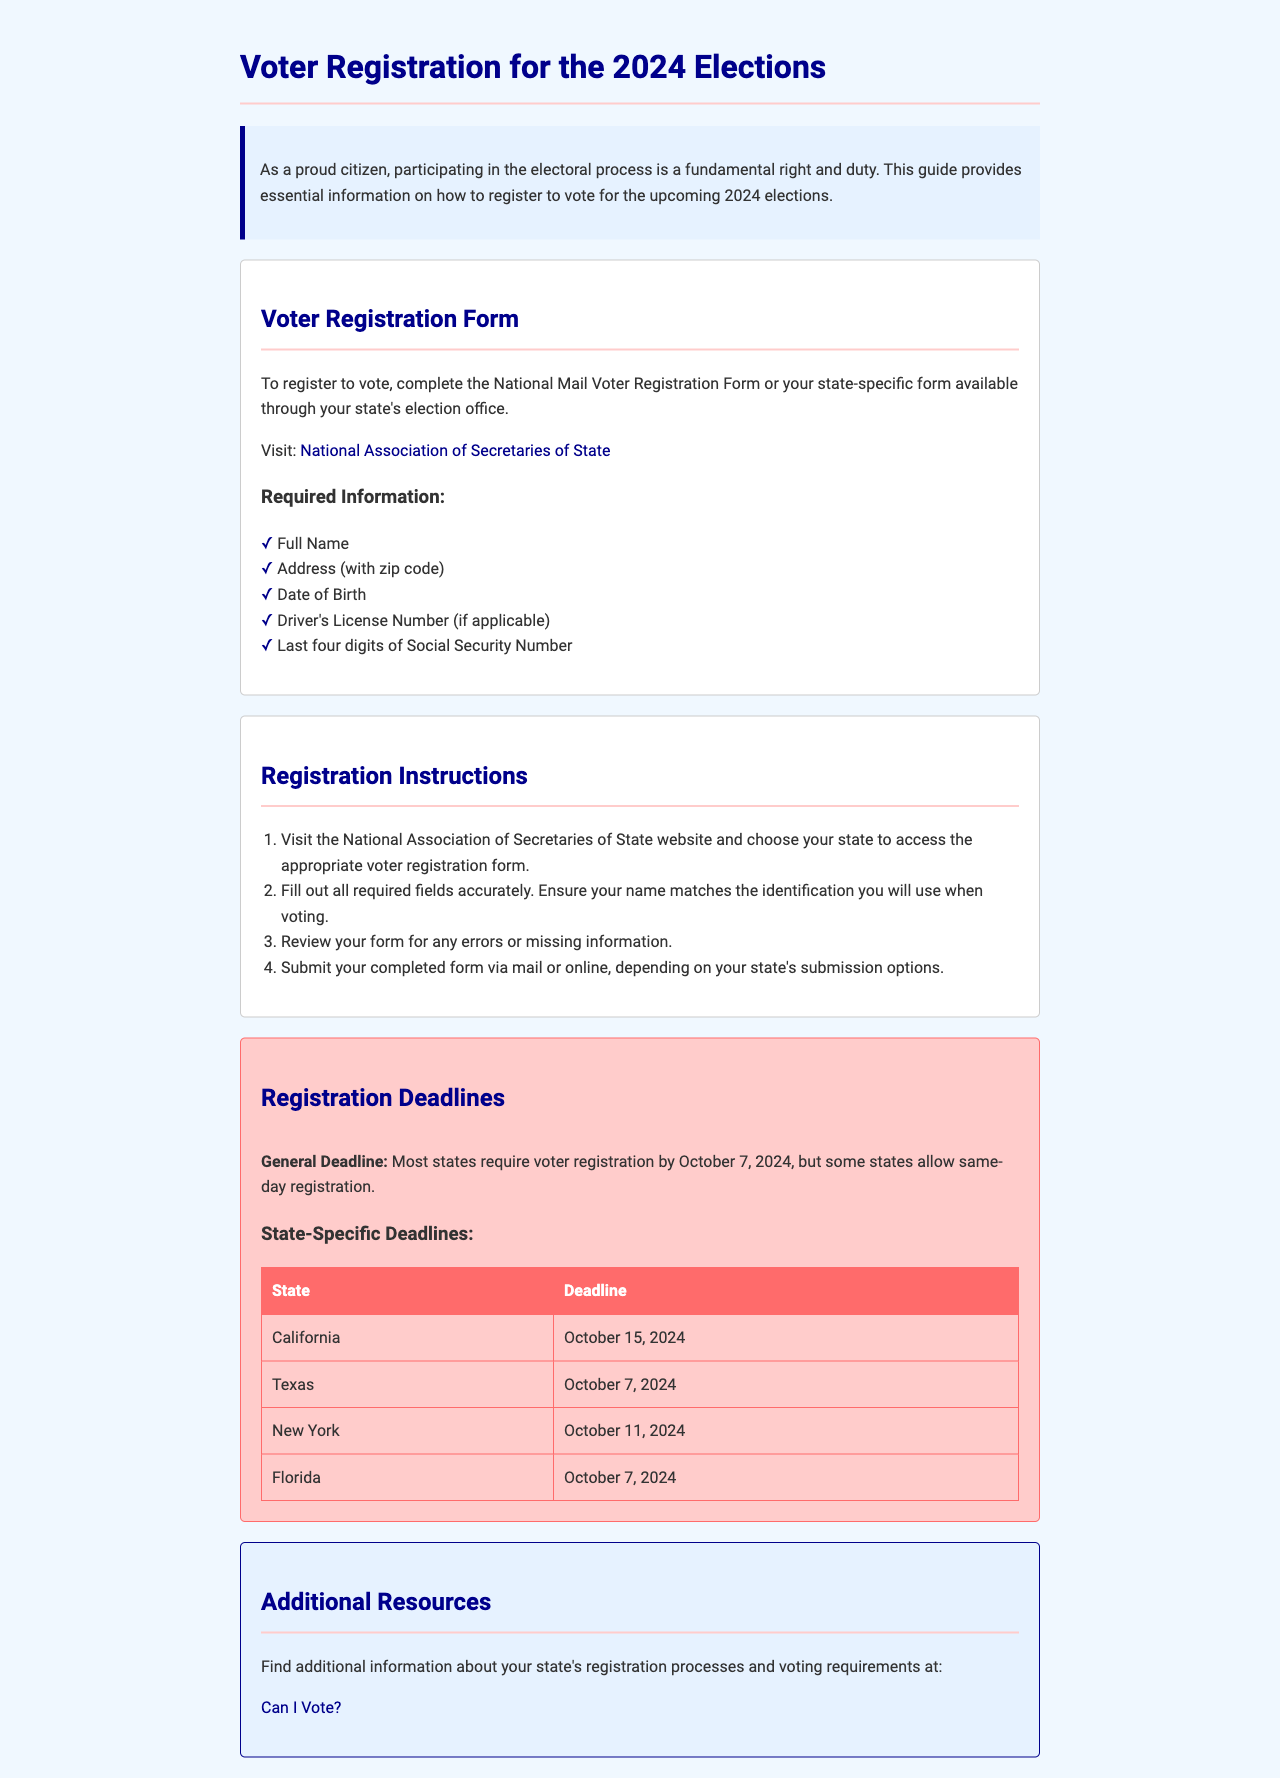what is the general registration deadline for most states? The general registration deadline is mentioned as October 7, 2024, for most states.
Answer: October 7, 2024 which state's registration deadline is the latest? The registration deadline for California is the latest among those listed.
Answer: October 15, 2024 what information is required to register to vote? The document specifies the required information, including full name, address, date of birth, driver's license number, and last four digits of Social Security number.
Answer: Full Name, Address, Date of Birth, Driver's License Number, Last four digits of Social Security Number what should you do after filling out the voter registration form? After filling out the form, you should review it for errors or missing information, as stated in the instructions.
Answer: Review for errors where can you find the appropriate voter registration form? The document directs you to visit the National Association of Secretaries of State website to access the appropriate form.
Answer: National Association of Secretaries of State website what is the resource provided for additional information about voting? The resource for additional information is the "Can I Vote?" website, as indicated in the document.
Answer: Can I Vote? 